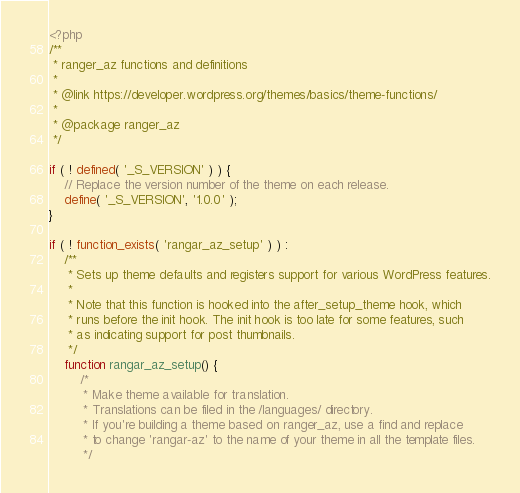Convert code to text. <code><loc_0><loc_0><loc_500><loc_500><_PHP_><?php
/**
 * ranger_az functions and definitions
 *
 * @link https://developer.wordpress.org/themes/basics/theme-functions/
 *
 * @package ranger_az
 */

if ( ! defined( '_S_VERSION' ) ) {
	// Replace the version number of the theme on each release.
	define( '_S_VERSION', '1.0.0' );
}

if ( ! function_exists( 'rangar_az_setup' ) ) :
	/**
	 * Sets up theme defaults and registers support for various WordPress features.
	 *
	 * Note that this function is hooked into the after_setup_theme hook, which
	 * runs before the init hook. The init hook is too late for some features, such
	 * as indicating support for post thumbnails.
	 */
	function rangar_az_setup() {
		/*
		 * Make theme available for translation.
		 * Translations can be filed in the /languages/ directory.
		 * If you're building a theme based on ranger_az, use a find and replace
		 * to change 'rangar-az' to the name of your theme in all the template files.
		 */</code> 